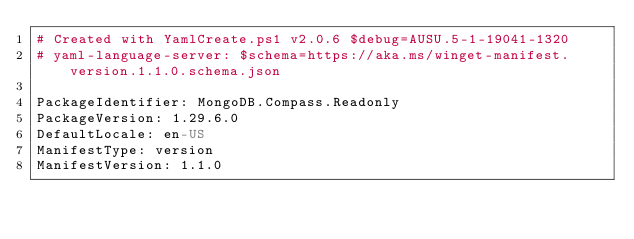Convert code to text. <code><loc_0><loc_0><loc_500><loc_500><_YAML_># Created with YamlCreate.ps1 v2.0.6 $debug=AUSU.5-1-19041-1320
# yaml-language-server: $schema=https://aka.ms/winget-manifest.version.1.1.0.schema.json

PackageIdentifier: MongoDB.Compass.Readonly
PackageVersion: 1.29.6.0
DefaultLocale: en-US
ManifestType: version
ManifestVersion: 1.1.0
</code> 